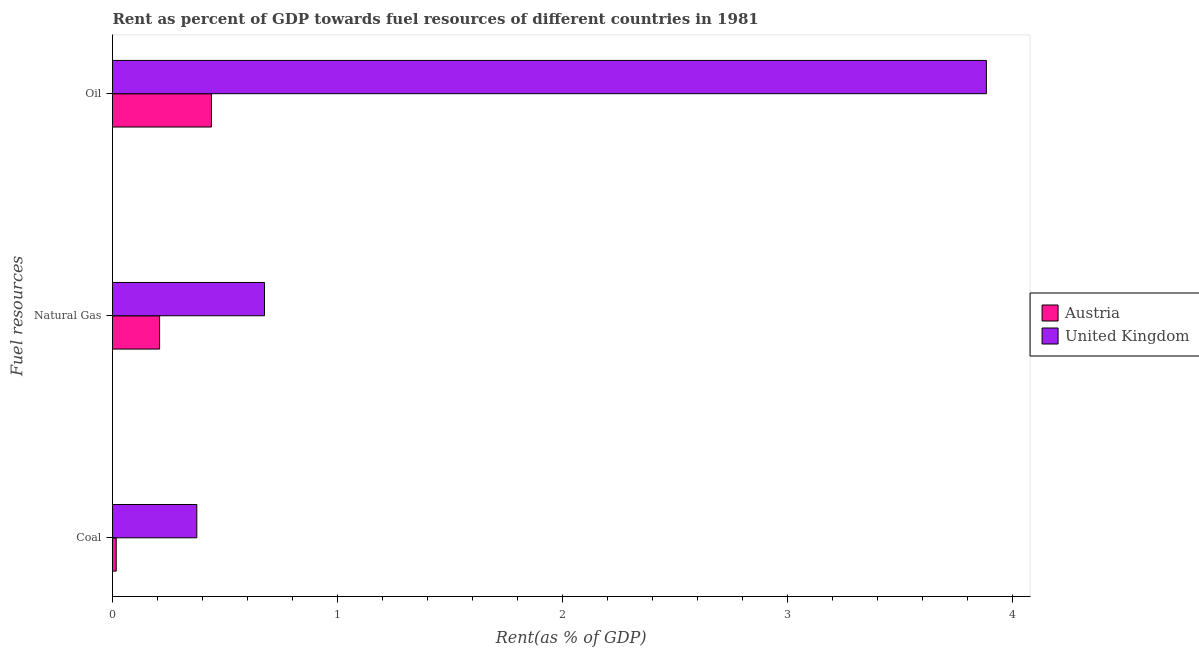How many different coloured bars are there?
Your response must be concise. 2. How many groups of bars are there?
Offer a very short reply. 3. Are the number of bars per tick equal to the number of legend labels?
Make the answer very short. Yes. How many bars are there on the 2nd tick from the bottom?
Provide a succinct answer. 2. What is the label of the 2nd group of bars from the top?
Provide a short and direct response. Natural Gas. What is the rent towards coal in Austria?
Provide a short and direct response. 0.02. Across all countries, what is the maximum rent towards oil?
Ensure brevity in your answer.  3.88. Across all countries, what is the minimum rent towards coal?
Provide a succinct answer. 0.02. In which country was the rent towards natural gas maximum?
Provide a succinct answer. United Kingdom. In which country was the rent towards coal minimum?
Offer a terse response. Austria. What is the total rent towards natural gas in the graph?
Offer a very short reply. 0.88. What is the difference between the rent towards natural gas in Austria and that in United Kingdom?
Make the answer very short. -0.47. What is the difference between the rent towards coal in Austria and the rent towards oil in United Kingdom?
Give a very brief answer. -3.87. What is the average rent towards coal per country?
Offer a very short reply. 0.2. What is the difference between the rent towards natural gas and rent towards oil in United Kingdom?
Offer a terse response. -3.21. What is the ratio of the rent towards oil in Austria to that in United Kingdom?
Keep it short and to the point. 0.11. Is the rent towards oil in Austria less than that in United Kingdom?
Make the answer very short. Yes. Is the difference between the rent towards oil in Austria and United Kingdom greater than the difference between the rent towards coal in Austria and United Kingdom?
Give a very brief answer. No. What is the difference between the highest and the second highest rent towards coal?
Your answer should be compact. 0.36. What is the difference between the highest and the lowest rent towards oil?
Your response must be concise. 3.44. Is the sum of the rent towards natural gas in Austria and United Kingdom greater than the maximum rent towards oil across all countries?
Offer a terse response. No. What does the 1st bar from the bottom in Natural Gas represents?
Your answer should be very brief. Austria. How many bars are there?
Give a very brief answer. 6. Are all the bars in the graph horizontal?
Your answer should be very brief. Yes. What is the difference between two consecutive major ticks on the X-axis?
Give a very brief answer. 1. What is the title of the graph?
Provide a short and direct response. Rent as percent of GDP towards fuel resources of different countries in 1981. What is the label or title of the X-axis?
Provide a succinct answer. Rent(as % of GDP). What is the label or title of the Y-axis?
Your response must be concise. Fuel resources. What is the Rent(as % of GDP) of Austria in Coal?
Give a very brief answer. 0.02. What is the Rent(as % of GDP) of United Kingdom in Coal?
Offer a very short reply. 0.37. What is the Rent(as % of GDP) in Austria in Natural Gas?
Your answer should be compact. 0.21. What is the Rent(as % of GDP) in United Kingdom in Natural Gas?
Offer a terse response. 0.68. What is the Rent(as % of GDP) of Austria in Oil?
Make the answer very short. 0.44. What is the Rent(as % of GDP) of United Kingdom in Oil?
Your answer should be very brief. 3.88. Across all Fuel resources, what is the maximum Rent(as % of GDP) in Austria?
Make the answer very short. 0.44. Across all Fuel resources, what is the maximum Rent(as % of GDP) in United Kingdom?
Your response must be concise. 3.88. Across all Fuel resources, what is the minimum Rent(as % of GDP) of Austria?
Make the answer very short. 0.02. Across all Fuel resources, what is the minimum Rent(as % of GDP) of United Kingdom?
Make the answer very short. 0.37. What is the total Rent(as % of GDP) in Austria in the graph?
Make the answer very short. 0.67. What is the total Rent(as % of GDP) in United Kingdom in the graph?
Offer a very short reply. 4.93. What is the difference between the Rent(as % of GDP) of Austria in Coal and that in Natural Gas?
Keep it short and to the point. -0.19. What is the difference between the Rent(as % of GDP) of United Kingdom in Coal and that in Natural Gas?
Provide a succinct answer. -0.3. What is the difference between the Rent(as % of GDP) of Austria in Coal and that in Oil?
Make the answer very short. -0.42. What is the difference between the Rent(as % of GDP) in United Kingdom in Coal and that in Oil?
Offer a terse response. -3.51. What is the difference between the Rent(as % of GDP) in Austria in Natural Gas and that in Oil?
Your response must be concise. -0.23. What is the difference between the Rent(as % of GDP) of United Kingdom in Natural Gas and that in Oil?
Your answer should be very brief. -3.21. What is the difference between the Rent(as % of GDP) in Austria in Coal and the Rent(as % of GDP) in United Kingdom in Natural Gas?
Offer a very short reply. -0.66. What is the difference between the Rent(as % of GDP) of Austria in Coal and the Rent(as % of GDP) of United Kingdom in Oil?
Your answer should be compact. -3.87. What is the difference between the Rent(as % of GDP) of Austria in Natural Gas and the Rent(as % of GDP) of United Kingdom in Oil?
Your answer should be very brief. -3.67. What is the average Rent(as % of GDP) of Austria per Fuel resources?
Your answer should be very brief. 0.22. What is the average Rent(as % of GDP) in United Kingdom per Fuel resources?
Your answer should be very brief. 1.64. What is the difference between the Rent(as % of GDP) in Austria and Rent(as % of GDP) in United Kingdom in Coal?
Offer a very short reply. -0.36. What is the difference between the Rent(as % of GDP) of Austria and Rent(as % of GDP) of United Kingdom in Natural Gas?
Make the answer very short. -0.47. What is the difference between the Rent(as % of GDP) of Austria and Rent(as % of GDP) of United Kingdom in Oil?
Provide a succinct answer. -3.44. What is the ratio of the Rent(as % of GDP) in Austria in Coal to that in Natural Gas?
Your answer should be compact. 0.08. What is the ratio of the Rent(as % of GDP) in United Kingdom in Coal to that in Natural Gas?
Your answer should be very brief. 0.55. What is the ratio of the Rent(as % of GDP) in Austria in Coal to that in Oil?
Give a very brief answer. 0.04. What is the ratio of the Rent(as % of GDP) in United Kingdom in Coal to that in Oil?
Provide a succinct answer. 0.1. What is the ratio of the Rent(as % of GDP) in Austria in Natural Gas to that in Oil?
Ensure brevity in your answer.  0.48. What is the ratio of the Rent(as % of GDP) of United Kingdom in Natural Gas to that in Oil?
Offer a terse response. 0.17. What is the difference between the highest and the second highest Rent(as % of GDP) in Austria?
Offer a terse response. 0.23. What is the difference between the highest and the second highest Rent(as % of GDP) in United Kingdom?
Your answer should be compact. 3.21. What is the difference between the highest and the lowest Rent(as % of GDP) in Austria?
Make the answer very short. 0.42. What is the difference between the highest and the lowest Rent(as % of GDP) in United Kingdom?
Your answer should be compact. 3.51. 